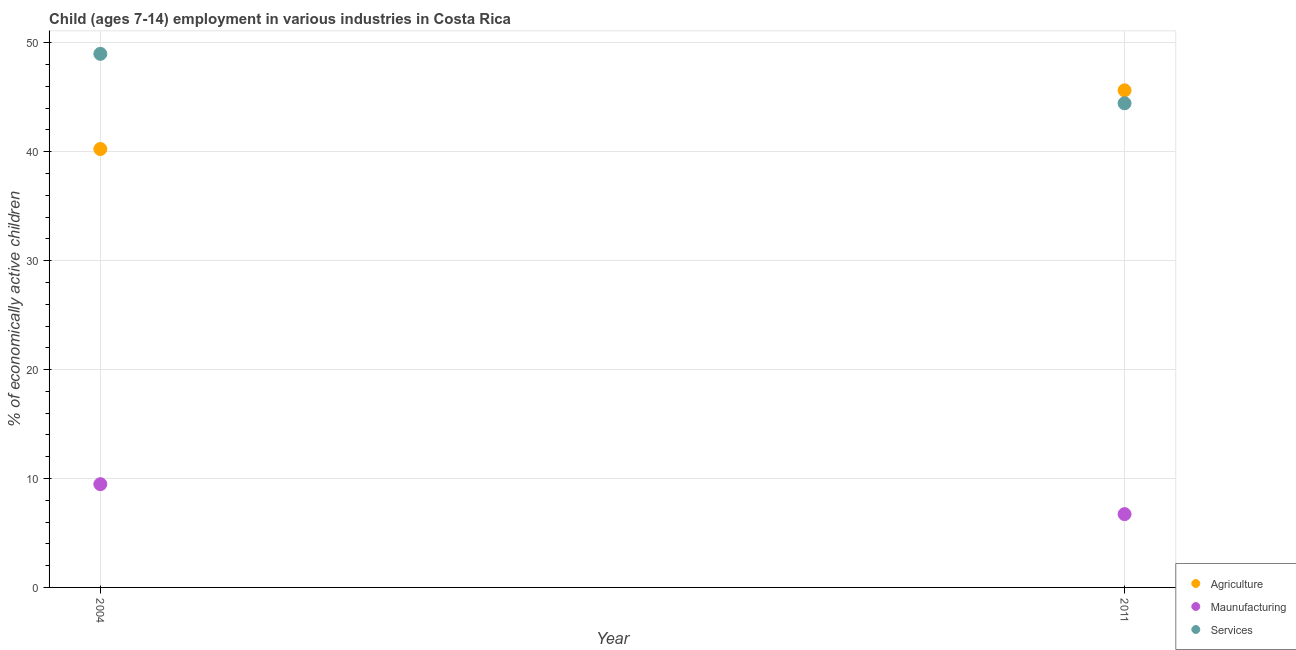What is the percentage of economically active children in manufacturing in 2011?
Your answer should be very brief. 6.73. Across all years, what is the maximum percentage of economically active children in services?
Give a very brief answer. 48.99. Across all years, what is the minimum percentage of economically active children in manufacturing?
Provide a short and direct response. 6.73. In which year was the percentage of economically active children in services minimum?
Give a very brief answer. 2011. What is the total percentage of economically active children in manufacturing in the graph?
Give a very brief answer. 16.21. What is the difference between the percentage of economically active children in agriculture in 2004 and that in 2011?
Your answer should be compact. -5.39. What is the difference between the percentage of economically active children in agriculture in 2011 and the percentage of economically active children in services in 2004?
Give a very brief answer. -3.35. What is the average percentage of economically active children in manufacturing per year?
Provide a succinct answer. 8.11. In the year 2011, what is the difference between the percentage of economically active children in services and percentage of economically active children in agriculture?
Keep it short and to the point. -1.19. What is the ratio of the percentage of economically active children in manufacturing in 2004 to that in 2011?
Give a very brief answer. 1.41. Is the percentage of economically active children in manufacturing in 2004 less than that in 2011?
Offer a terse response. No. How many years are there in the graph?
Ensure brevity in your answer.  2. What is the difference between two consecutive major ticks on the Y-axis?
Your answer should be very brief. 10. Are the values on the major ticks of Y-axis written in scientific E-notation?
Make the answer very short. No. Does the graph contain any zero values?
Your response must be concise. No. Does the graph contain grids?
Your answer should be very brief. Yes. How are the legend labels stacked?
Offer a terse response. Vertical. What is the title of the graph?
Give a very brief answer. Child (ages 7-14) employment in various industries in Costa Rica. What is the label or title of the X-axis?
Ensure brevity in your answer.  Year. What is the label or title of the Y-axis?
Keep it short and to the point. % of economically active children. What is the % of economically active children in Agriculture in 2004?
Keep it short and to the point. 40.25. What is the % of economically active children of Maunufacturing in 2004?
Your answer should be compact. 9.48. What is the % of economically active children in Services in 2004?
Provide a short and direct response. 48.99. What is the % of economically active children in Agriculture in 2011?
Your answer should be very brief. 45.64. What is the % of economically active children of Maunufacturing in 2011?
Ensure brevity in your answer.  6.73. What is the % of economically active children in Services in 2011?
Offer a very short reply. 44.45. Across all years, what is the maximum % of economically active children in Agriculture?
Offer a terse response. 45.64. Across all years, what is the maximum % of economically active children in Maunufacturing?
Your answer should be very brief. 9.48. Across all years, what is the maximum % of economically active children of Services?
Keep it short and to the point. 48.99. Across all years, what is the minimum % of economically active children in Agriculture?
Make the answer very short. 40.25. Across all years, what is the minimum % of economically active children in Maunufacturing?
Make the answer very short. 6.73. Across all years, what is the minimum % of economically active children of Services?
Offer a very short reply. 44.45. What is the total % of economically active children in Agriculture in the graph?
Offer a very short reply. 85.89. What is the total % of economically active children of Maunufacturing in the graph?
Ensure brevity in your answer.  16.21. What is the total % of economically active children of Services in the graph?
Your answer should be very brief. 93.44. What is the difference between the % of economically active children in Agriculture in 2004 and that in 2011?
Make the answer very short. -5.39. What is the difference between the % of economically active children in Maunufacturing in 2004 and that in 2011?
Your answer should be compact. 2.75. What is the difference between the % of economically active children in Services in 2004 and that in 2011?
Ensure brevity in your answer.  4.54. What is the difference between the % of economically active children in Agriculture in 2004 and the % of economically active children in Maunufacturing in 2011?
Provide a short and direct response. 33.52. What is the difference between the % of economically active children of Maunufacturing in 2004 and the % of economically active children of Services in 2011?
Your answer should be compact. -34.97. What is the average % of economically active children of Agriculture per year?
Keep it short and to the point. 42.95. What is the average % of economically active children in Maunufacturing per year?
Your answer should be compact. 8.11. What is the average % of economically active children in Services per year?
Ensure brevity in your answer.  46.72. In the year 2004, what is the difference between the % of economically active children in Agriculture and % of economically active children in Maunufacturing?
Provide a succinct answer. 30.77. In the year 2004, what is the difference between the % of economically active children of Agriculture and % of economically active children of Services?
Provide a short and direct response. -8.74. In the year 2004, what is the difference between the % of economically active children of Maunufacturing and % of economically active children of Services?
Your answer should be very brief. -39.51. In the year 2011, what is the difference between the % of economically active children in Agriculture and % of economically active children in Maunufacturing?
Make the answer very short. 38.91. In the year 2011, what is the difference between the % of economically active children in Agriculture and % of economically active children in Services?
Offer a terse response. 1.19. In the year 2011, what is the difference between the % of economically active children in Maunufacturing and % of economically active children in Services?
Provide a succinct answer. -37.72. What is the ratio of the % of economically active children in Agriculture in 2004 to that in 2011?
Your answer should be very brief. 0.88. What is the ratio of the % of economically active children in Maunufacturing in 2004 to that in 2011?
Provide a short and direct response. 1.41. What is the ratio of the % of economically active children of Services in 2004 to that in 2011?
Keep it short and to the point. 1.1. What is the difference between the highest and the second highest % of economically active children in Agriculture?
Your answer should be very brief. 5.39. What is the difference between the highest and the second highest % of economically active children of Maunufacturing?
Provide a short and direct response. 2.75. What is the difference between the highest and the second highest % of economically active children of Services?
Provide a short and direct response. 4.54. What is the difference between the highest and the lowest % of economically active children in Agriculture?
Make the answer very short. 5.39. What is the difference between the highest and the lowest % of economically active children of Maunufacturing?
Offer a very short reply. 2.75. What is the difference between the highest and the lowest % of economically active children in Services?
Your response must be concise. 4.54. 